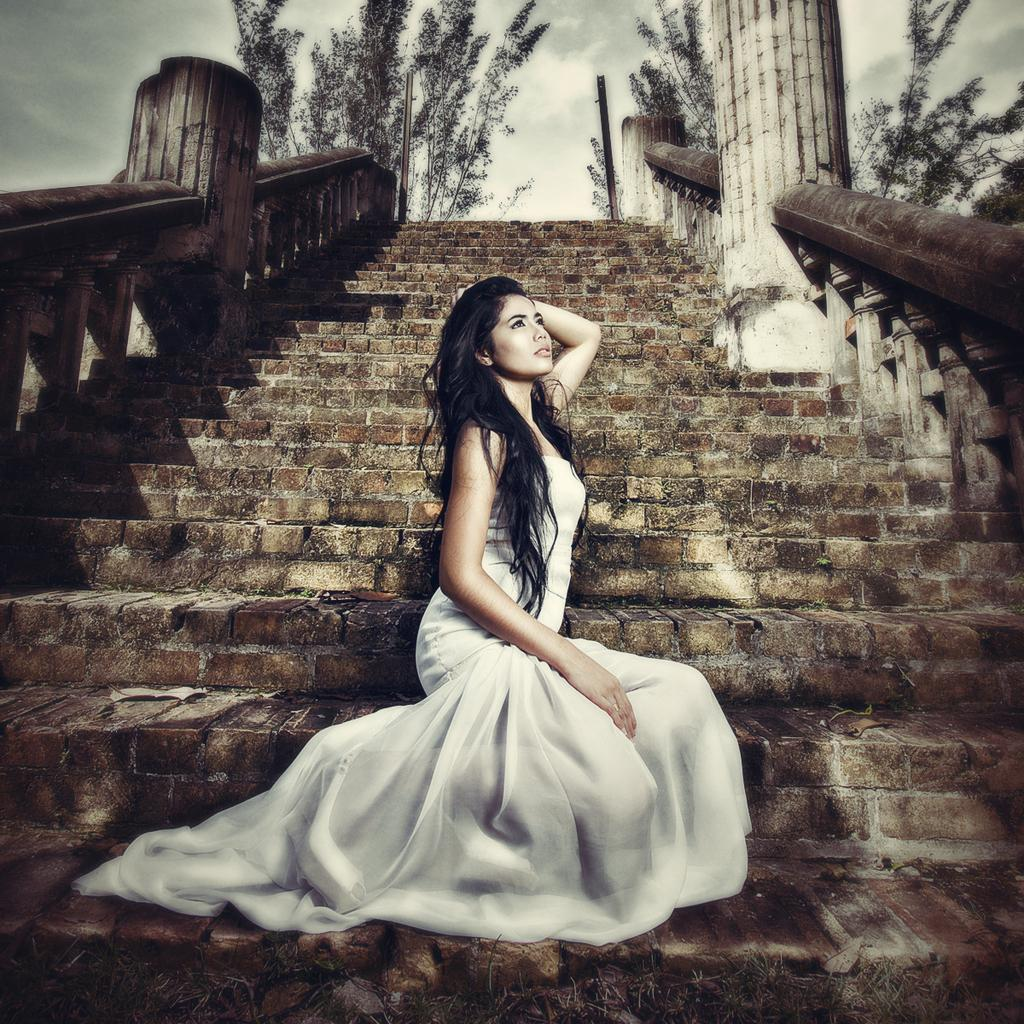Who is the main subject in the image? There is a woman in the image. What is the woman doing in the image? The woman is sitting on steps. What type of natural environment can be seen in the image? Trees are visible in the image. What is visible in the background of the image? The sky is visible in the background of the image. What can be observed in the sky? Clouds are present in the sky. What type of wax is being used by the woman to sculpt a worm on her knee in the image? There is no wax, worm, or sculpting activity present in the image. 